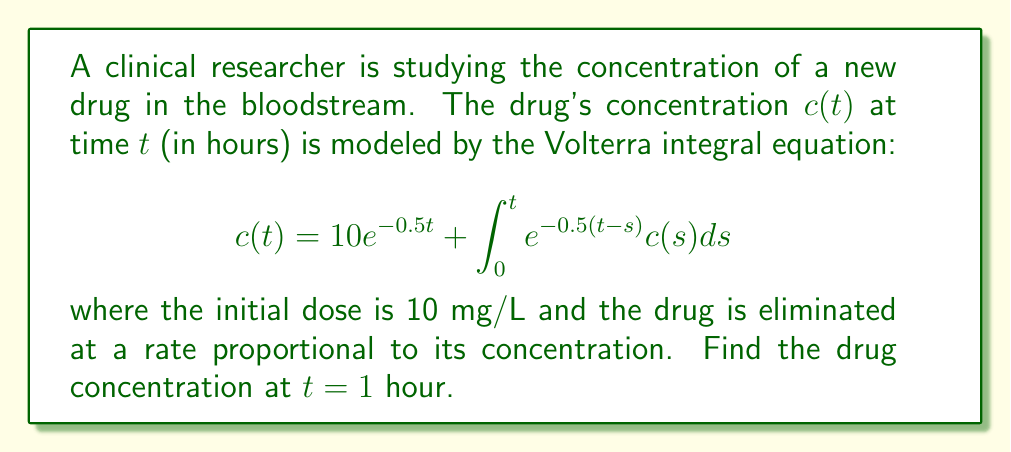Can you solve this math problem? To solve this Volterra integral equation, we'll use the Laplace transform method:

1) Take the Laplace transform of both sides:
   $$\mathcal{L}\{c(t)\} = \mathcal{L}\{10e^{-0.5t}\} + \mathcal{L}\{\int_0^t e^{-0.5(t-s)}c(s)ds\}$$

2) Let $C(s)$ be the Laplace transform of $c(t)$. Using Laplace transform properties:
   $$C(s) = \frac{10}{s+0.5} + \frac{1}{s+0.5}C(s)$$

3) Solve for $C(s)$:
   $$C(s) - \frac{1}{s+0.5}C(s) = \frac{10}{s+0.5}$$
   $$C(s)\left(1 - \frac{1}{s+0.5}\right) = \frac{10}{s+0.5}$$
   $$C(s)\left(\frac{s+0.5-1}{s+0.5}\right) = \frac{10}{s+0.5}$$
   $$C(s) = \frac{10}{s-0.5}$$

4) Take the inverse Laplace transform:
   $$c(t) = 10e^{0.5t}$$

5) Evaluate at $t=1$:
   $$c(1) = 10e^{0.5} \approx 16.4872$$

Therefore, the drug concentration at $t=1$ hour is approximately 16.4872 mg/L.
Answer: $16.4872$ mg/L 